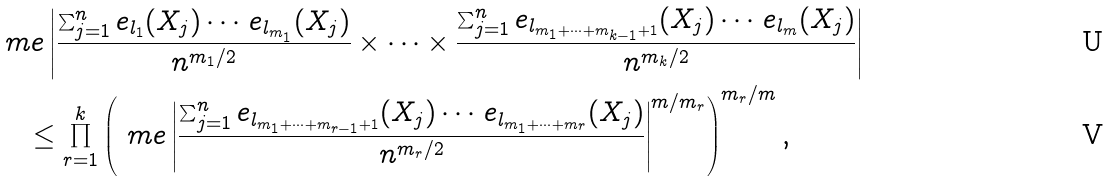<formula> <loc_0><loc_0><loc_500><loc_500>& \ m e \left | \frac { \sum _ { j = 1 } ^ { n } e _ { l _ { 1 } } ( X _ { j } ) \cdots \, e _ { l _ { m _ { 1 } } } ( X _ { j } ) } { n ^ { m _ { 1 } / 2 } } \times \dots \times \frac { \sum _ { j = 1 } ^ { n } e _ { l _ { m _ { 1 } + \cdots + m _ { k - 1 } + 1 } } ( X _ { j } ) \cdots \, e _ { l _ { m } } ( X _ { j } ) } { n ^ { m _ { k } / 2 } } \right | \\ & \quad \leq \prod _ { r = 1 } ^ { k } \left ( \ m e \left | \frac { \sum _ { j = 1 } ^ { n } e _ { l _ { m _ { 1 } + \cdots + m _ { r - 1 } + 1 } } ( X _ { j } ) \cdots \, e _ { l _ { m _ { 1 } + \cdots + m _ { r } } } ( X _ { j } ) } { n ^ { m _ { r } / 2 } } \right | ^ { m / m _ { r } } \right ) ^ { m _ { r } / m } ,</formula> 